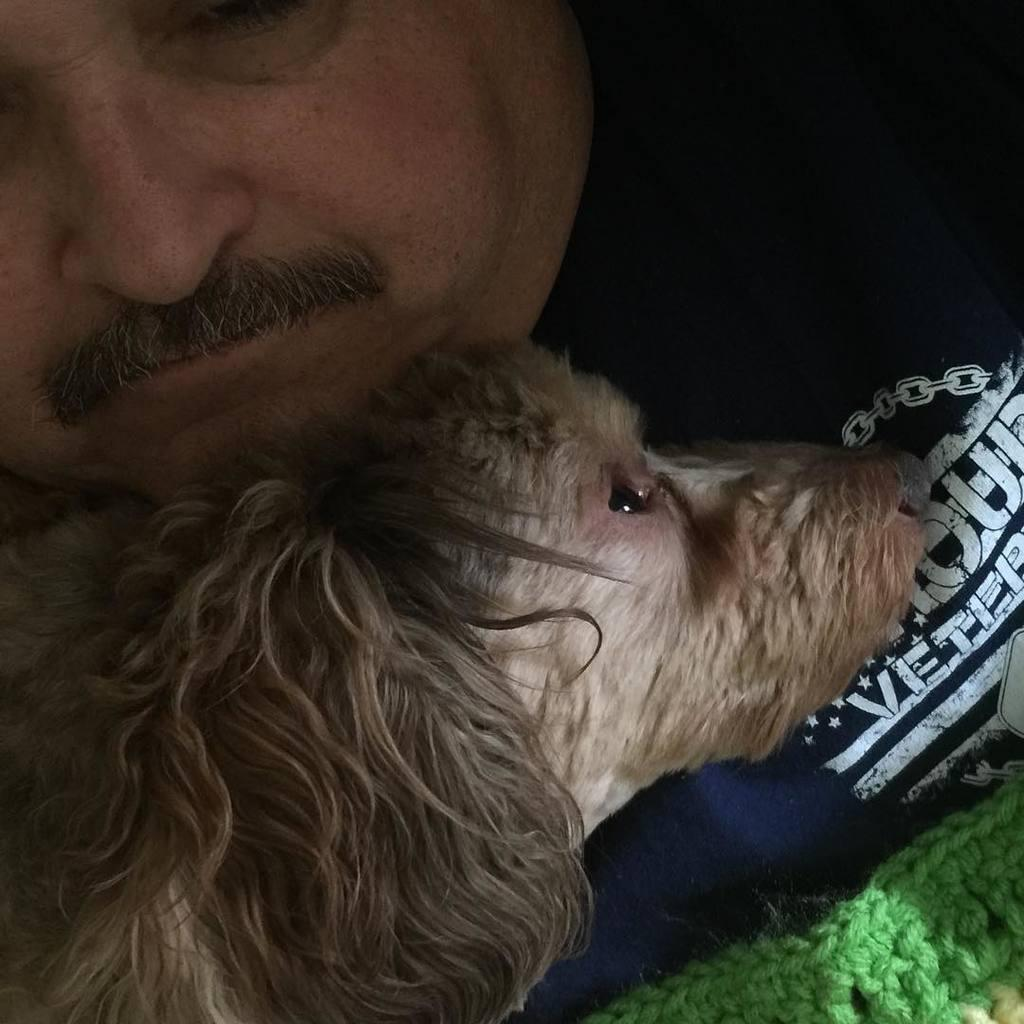What is the main subject of the image? There is a person in the image. Can you describe the person's appearance? The person has a mustache and is wearing a black t-shirt. What is the person holding in the image? The person is holding a dog. Can you describe the dog's appearance? The dog is brown in color. What type of whistle does the person use to communicate with the dog in the image? There is no whistle present in the image; the person is holding a dog, but no whistle is visible. 